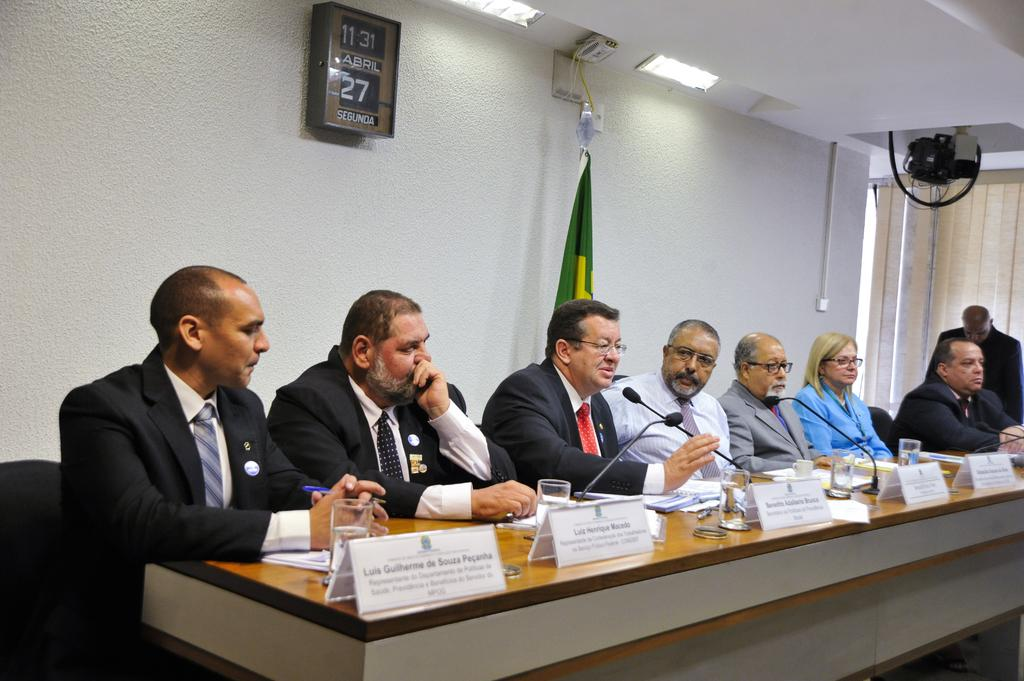What are the people in the image doing? The people in the image are seated on chairs. What is in front of the people? There is a table in front of the people. What can be seen on the table? There are glasses, name plates, and microphones on the table. What is on the wall behind the people? There is a clock and a flag on the wall. How many wristwatches are visible on the people in the image? There is no mention of wristwatches in the image, so it is impossible to determine their presence or quantity. 